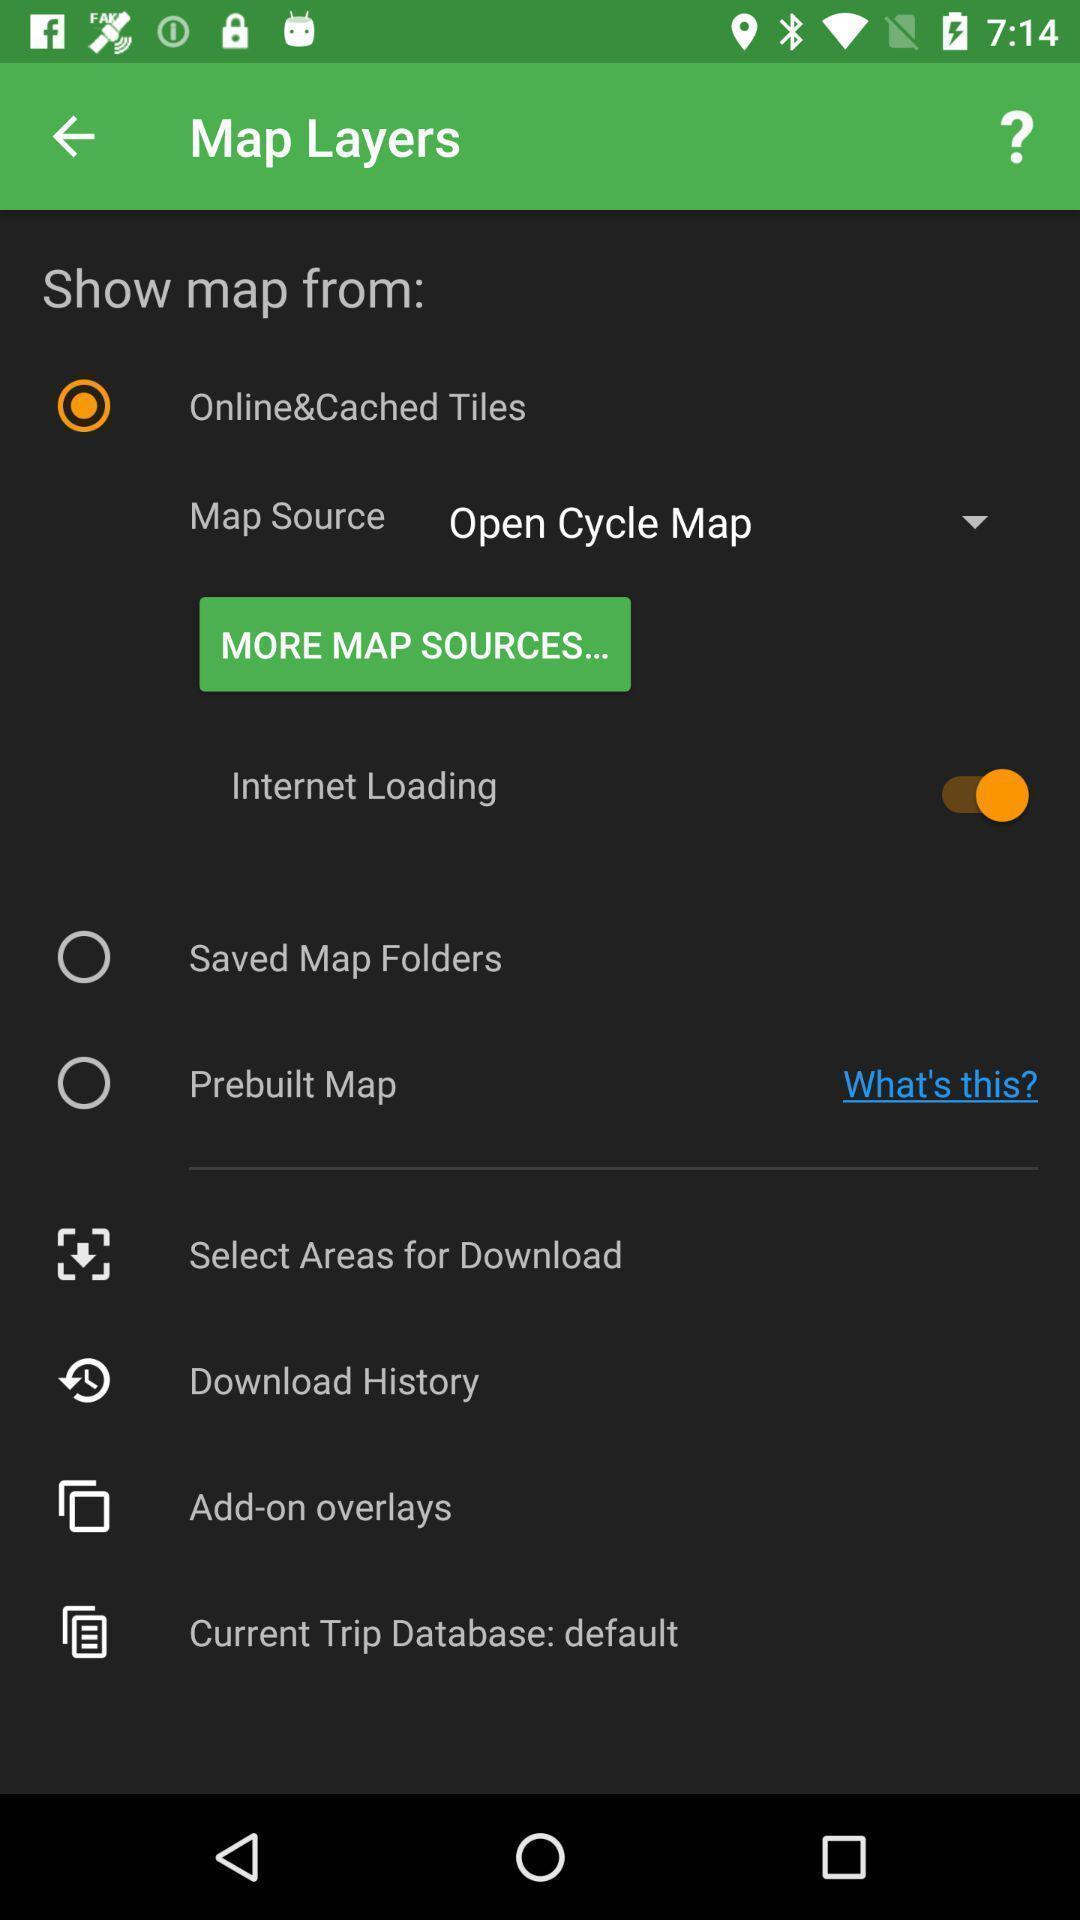Please provide a description for this image. Screen displaying settings under map layers page. 